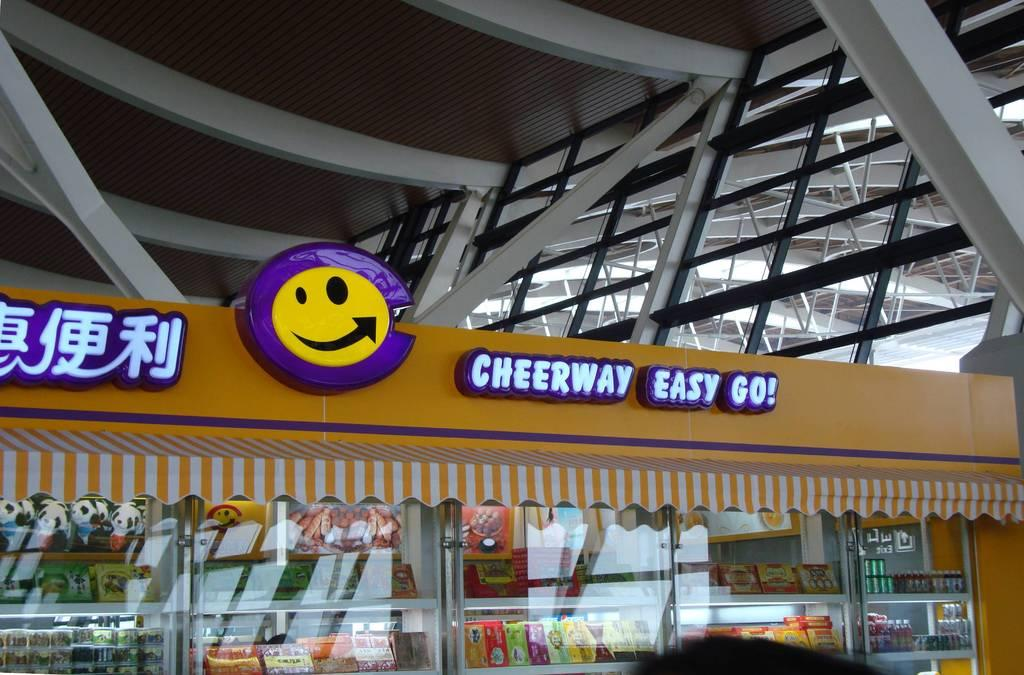What type of structure is present in the image? There is a stall in the image. What can be seen on the stall? The stall has a picture and some text. What are the rods used for in the image? The rods are likely used for supporting or stabilizing the stall. What covers the top of the stall in the image? There is a roof in the image. How does the stall laugh in the image? The stall does not laugh in the image; it is an inanimate object. 